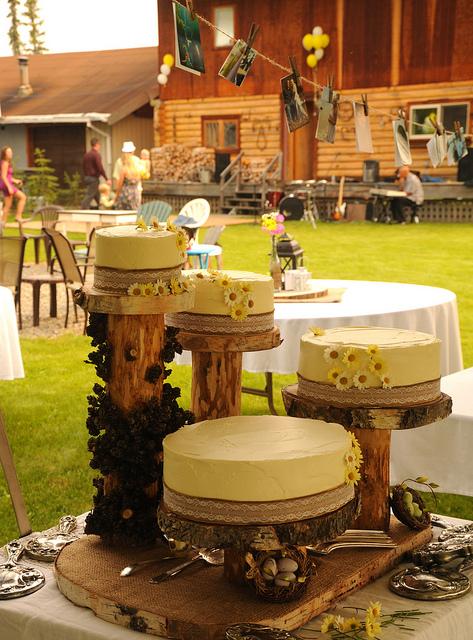What is the bottom of the building made of?
Be succinct. Wood. Are there more than one cake on display?
Give a very brief answer. Yes. How are the cakes decorated?
Keep it brief. With flowers. 